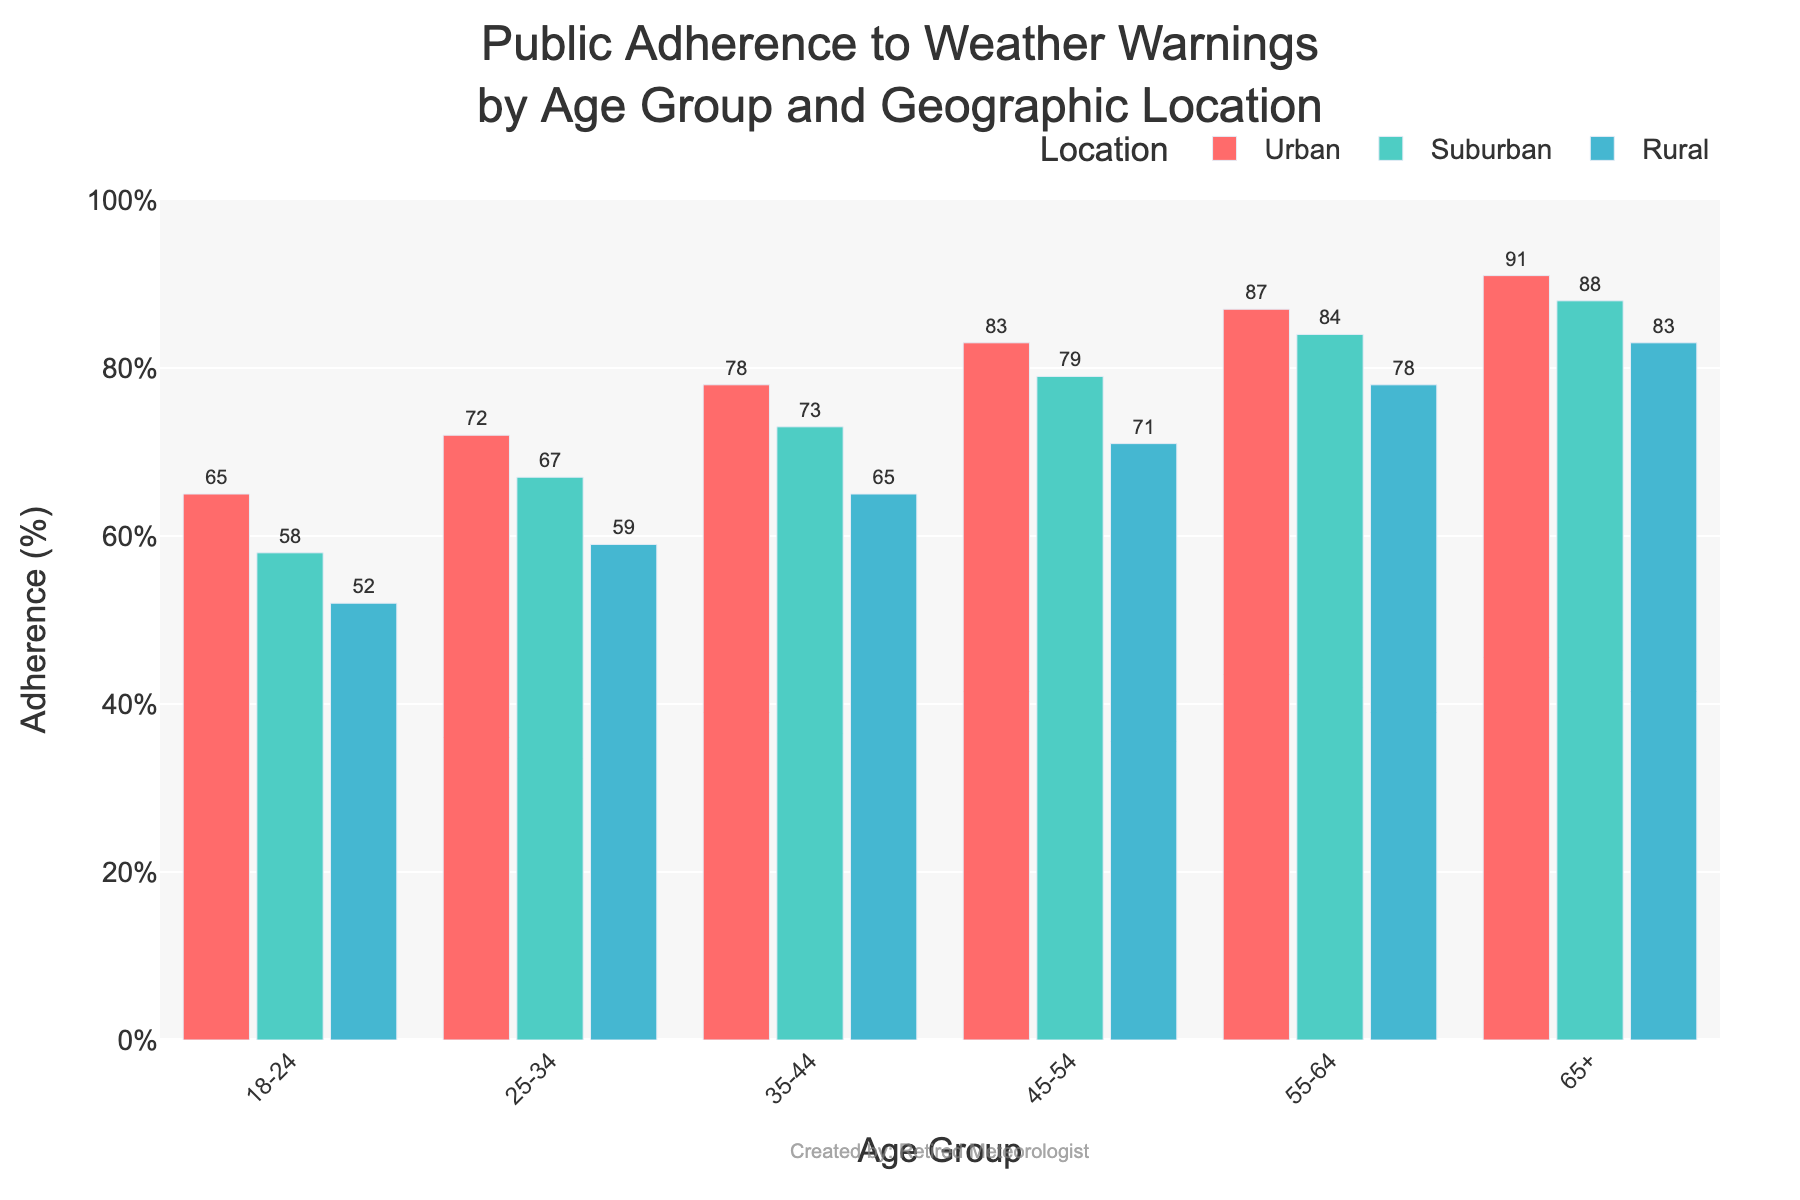Which age group has the highest adherence to weather warnings in rural areas? The age group with the highest adherence to weather warnings in rural areas can be found by comparing the heights of the blue bars representing the rural areas. The tallest rural bar corresponds to the 65+ age group.
Answer: 65+ How much higher is the adherence to weather warnings in Urban areas for the 65+ age group compared to the 18-24 age group? To find the difference in adherence, subtract the percentage for the 18-24 age group from the percentage for the 65+ age group in Urban areas. This yields 91% - 65% = 26%.
Answer: 26% Which location shows the least adherence to weather warnings for the 25-34 age group? To determine the location with the least adherence for the 25-34 age group, compare the heights of the bars corresponding to this age group. The shortest bar among Urban, Suburban, and Rural indicates the Rural area at 59%.
Answer: Rural What is the average adherence to weather warnings for the 45-54 age group across all locations? To find the average adherence, sum the values of adherence across Urban, Suburban, and Rural areas for the 45-54 age group and divide by the number of locations. (83 + 79 + 71) / 3 = 77.67%.
Answer: 77.67% Which location has the highest overall average adherence to weather warnings across all age groups? Calculate the average adherence per location by summing the adherence percentages for each age group within a location and dividing by the number of age groups. Urban: (65+72+78+83+87+91)/6, Suburban: (58+67+73+79+84+88)/6, Rural: (52+59+65+71+78+83)/6. The highest average adherence is found in Urban areas with (65 + 72 + 78 + 83 + 87 + 91) / 6 = 79.33%.
Answer: Urban Between Suburban and Rural areas, which one has a higher adherence to weather warnings for the 55-64 age group, and by how much? To determine the higher adherence, compare the bars for Suburban and Rural areas in the 55-64 age group. Suburban has 84% and Rural has 78%. The difference is 84% - 78% = 6%.
Answer: Suburban, by 6% What percentage of the 35-44 age group adheres to weather warnings in Suburban areas, and what color represents this data? Look at the bar corresponding to the 35-44 age group in Suburban areas to determine the percentage, which is represented by the teal-colored bar. The percentage is 73%.
Answer: 73%, teal Does the adherence to weather warnings increase or decrease with age in Urban areas? By observing the trend of the red bars from the 18-24 age group to the 65+ age group, it is evident that adherence increases with age.
Answer: Increases What percentage of the 25-34 age group adheres to weather warnings in Rural areas, and how does this compare to the 35-44 age group in the same location? Look at the bars for the 25-34 and 35-44 age groups in the Rural areas. The adherence is 59% for 25-34 and 65% for 35-44. To compare, subtract 59% from 65%, which gives a difference of 6%.
Answer: 25-34: 59%, 6% higher for 35-44 